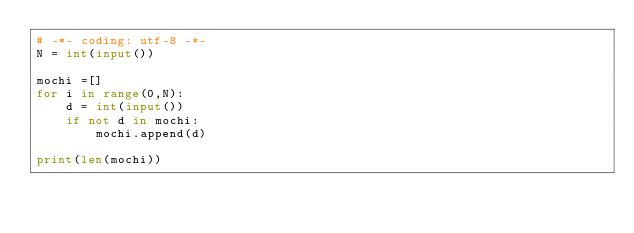Convert code to text. <code><loc_0><loc_0><loc_500><loc_500><_Python_># -*- coding: utf-8 -*-
N = int(input())

mochi =[]
for i in range(0,N):
    d = int(input())
    if not d in mochi:
        mochi.append(d)

print(len(mochi))</code> 